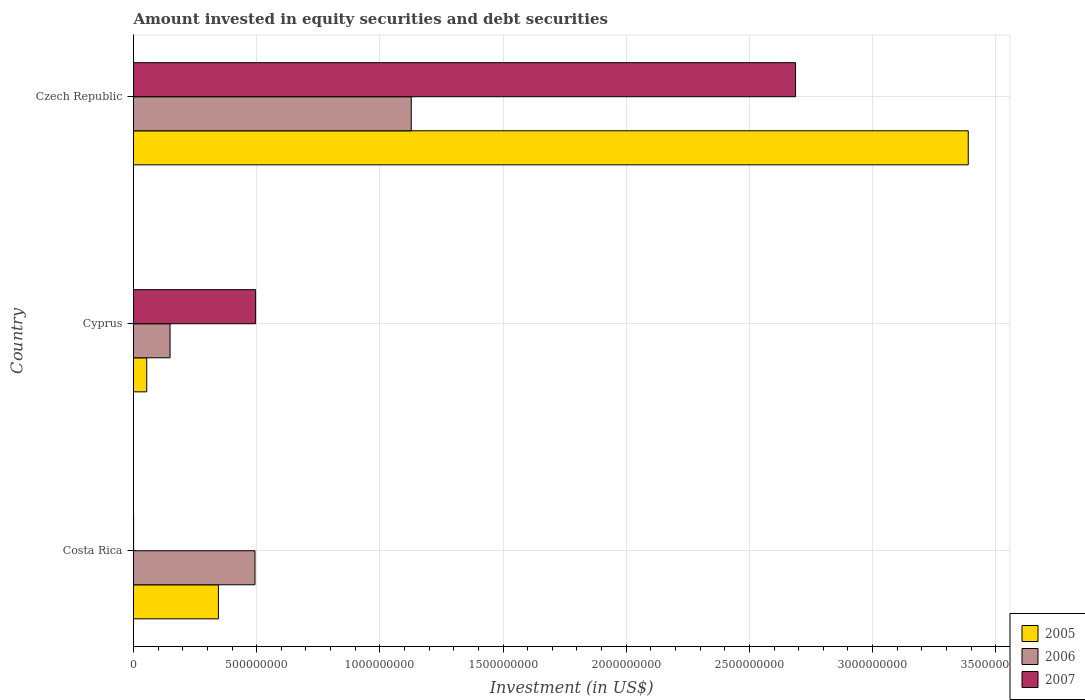How many different coloured bars are there?
Your answer should be compact. 3. How many groups of bars are there?
Give a very brief answer. 3. Are the number of bars on each tick of the Y-axis equal?
Your answer should be very brief. Yes. How many bars are there on the 3rd tick from the top?
Your response must be concise. 3. What is the label of the 2nd group of bars from the top?
Provide a succinct answer. Cyprus. What is the amount invested in equity securities and debt securities in 2006 in Costa Rica?
Ensure brevity in your answer.  4.93e+08. Across all countries, what is the maximum amount invested in equity securities and debt securities in 2005?
Offer a very short reply. 3.39e+09. Across all countries, what is the minimum amount invested in equity securities and debt securities in 2007?
Your response must be concise. 3.93e+05. In which country was the amount invested in equity securities and debt securities in 2006 maximum?
Give a very brief answer. Czech Republic. In which country was the amount invested in equity securities and debt securities in 2007 minimum?
Make the answer very short. Costa Rica. What is the total amount invested in equity securities and debt securities in 2005 in the graph?
Your answer should be very brief. 3.79e+09. What is the difference between the amount invested in equity securities and debt securities in 2006 in Costa Rica and that in Czech Republic?
Provide a succinct answer. -6.34e+08. What is the difference between the amount invested in equity securities and debt securities in 2005 in Czech Republic and the amount invested in equity securities and debt securities in 2006 in Costa Rica?
Provide a succinct answer. 2.90e+09. What is the average amount invested in equity securities and debt securities in 2007 per country?
Provide a short and direct response. 1.06e+09. What is the difference between the amount invested in equity securities and debt securities in 2007 and amount invested in equity securities and debt securities in 2005 in Costa Rica?
Offer a very short reply. -3.44e+08. In how many countries, is the amount invested in equity securities and debt securities in 2006 greater than 300000000 US$?
Your answer should be very brief. 2. What is the ratio of the amount invested in equity securities and debt securities in 2006 in Costa Rica to that in Czech Republic?
Offer a terse response. 0.44. Is the amount invested in equity securities and debt securities in 2005 in Costa Rica less than that in Cyprus?
Offer a very short reply. No. Is the difference between the amount invested in equity securities and debt securities in 2007 in Cyprus and Czech Republic greater than the difference between the amount invested in equity securities and debt securities in 2005 in Cyprus and Czech Republic?
Offer a very short reply. Yes. What is the difference between the highest and the second highest amount invested in equity securities and debt securities in 2005?
Your response must be concise. 3.04e+09. What is the difference between the highest and the lowest amount invested in equity securities and debt securities in 2005?
Offer a terse response. 3.33e+09. In how many countries, is the amount invested in equity securities and debt securities in 2006 greater than the average amount invested in equity securities and debt securities in 2006 taken over all countries?
Ensure brevity in your answer.  1. Is the sum of the amount invested in equity securities and debt securities in 2007 in Cyprus and Czech Republic greater than the maximum amount invested in equity securities and debt securities in 2005 across all countries?
Give a very brief answer. No. What does the 1st bar from the bottom in Czech Republic represents?
Make the answer very short. 2005. Is it the case that in every country, the sum of the amount invested in equity securities and debt securities in 2005 and amount invested in equity securities and debt securities in 2006 is greater than the amount invested in equity securities and debt securities in 2007?
Ensure brevity in your answer.  No. How many bars are there?
Offer a terse response. 9. How many countries are there in the graph?
Give a very brief answer. 3. Where does the legend appear in the graph?
Provide a short and direct response. Bottom right. How many legend labels are there?
Provide a succinct answer. 3. How are the legend labels stacked?
Your answer should be very brief. Vertical. What is the title of the graph?
Offer a very short reply. Amount invested in equity securities and debt securities. Does "1966" appear as one of the legend labels in the graph?
Your response must be concise. No. What is the label or title of the X-axis?
Give a very brief answer. Investment (in US$). What is the Investment (in US$) in 2005 in Costa Rica?
Your response must be concise. 3.45e+08. What is the Investment (in US$) of 2006 in Costa Rica?
Your response must be concise. 4.93e+08. What is the Investment (in US$) in 2007 in Costa Rica?
Make the answer very short. 3.93e+05. What is the Investment (in US$) of 2005 in Cyprus?
Offer a terse response. 5.37e+07. What is the Investment (in US$) of 2006 in Cyprus?
Provide a short and direct response. 1.48e+08. What is the Investment (in US$) of 2007 in Cyprus?
Your response must be concise. 4.96e+08. What is the Investment (in US$) in 2005 in Czech Republic?
Provide a short and direct response. 3.39e+09. What is the Investment (in US$) of 2006 in Czech Republic?
Your answer should be very brief. 1.13e+09. What is the Investment (in US$) of 2007 in Czech Republic?
Provide a short and direct response. 2.69e+09. Across all countries, what is the maximum Investment (in US$) in 2005?
Offer a very short reply. 3.39e+09. Across all countries, what is the maximum Investment (in US$) in 2006?
Provide a succinct answer. 1.13e+09. Across all countries, what is the maximum Investment (in US$) of 2007?
Your response must be concise. 2.69e+09. Across all countries, what is the minimum Investment (in US$) in 2005?
Offer a terse response. 5.37e+07. Across all countries, what is the minimum Investment (in US$) in 2006?
Your answer should be compact. 1.48e+08. Across all countries, what is the minimum Investment (in US$) in 2007?
Keep it short and to the point. 3.93e+05. What is the total Investment (in US$) in 2005 in the graph?
Keep it short and to the point. 3.79e+09. What is the total Investment (in US$) in 2006 in the graph?
Offer a very short reply. 1.77e+09. What is the total Investment (in US$) of 2007 in the graph?
Give a very brief answer. 3.18e+09. What is the difference between the Investment (in US$) in 2005 in Costa Rica and that in Cyprus?
Give a very brief answer. 2.91e+08. What is the difference between the Investment (in US$) of 2006 in Costa Rica and that in Cyprus?
Provide a short and direct response. 3.45e+08. What is the difference between the Investment (in US$) of 2007 in Costa Rica and that in Cyprus?
Give a very brief answer. -4.95e+08. What is the difference between the Investment (in US$) of 2005 in Costa Rica and that in Czech Republic?
Provide a short and direct response. -3.04e+09. What is the difference between the Investment (in US$) of 2006 in Costa Rica and that in Czech Republic?
Your response must be concise. -6.34e+08. What is the difference between the Investment (in US$) of 2007 in Costa Rica and that in Czech Republic?
Provide a short and direct response. -2.69e+09. What is the difference between the Investment (in US$) of 2005 in Cyprus and that in Czech Republic?
Provide a short and direct response. -3.33e+09. What is the difference between the Investment (in US$) in 2006 in Cyprus and that in Czech Republic?
Keep it short and to the point. -9.79e+08. What is the difference between the Investment (in US$) of 2007 in Cyprus and that in Czech Republic?
Offer a very short reply. -2.19e+09. What is the difference between the Investment (in US$) in 2005 in Costa Rica and the Investment (in US$) in 2006 in Cyprus?
Provide a short and direct response. 1.96e+08. What is the difference between the Investment (in US$) of 2005 in Costa Rica and the Investment (in US$) of 2007 in Cyprus?
Make the answer very short. -1.51e+08. What is the difference between the Investment (in US$) of 2006 in Costa Rica and the Investment (in US$) of 2007 in Cyprus?
Give a very brief answer. -2.46e+06. What is the difference between the Investment (in US$) in 2005 in Costa Rica and the Investment (in US$) in 2006 in Czech Republic?
Keep it short and to the point. -7.83e+08. What is the difference between the Investment (in US$) in 2005 in Costa Rica and the Investment (in US$) in 2007 in Czech Republic?
Ensure brevity in your answer.  -2.34e+09. What is the difference between the Investment (in US$) of 2006 in Costa Rica and the Investment (in US$) of 2007 in Czech Republic?
Your answer should be compact. -2.19e+09. What is the difference between the Investment (in US$) of 2005 in Cyprus and the Investment (in US$) of 2006 in Czech Republic?
Provide a short and direct response. -1.07e+09. What is the difference between the Investment (in US$) of 2005 in Cyprus and the Investment (in US$) of 2007 in Czech Republic?
Provide a short and direct response. -2.63e+09. What is the difference between the Investment (in US$) in 2006 in Cyprus and the Investment (in US$) in 2007 in Czech Republic?
Provide a short and direct response. -2.54e+09. What is the average Investment (in US$) in 2005 per country?
Offer a very short reply. 1.26e+09. What is the average Investment (in US$) of 2006 per country?
Provide a short and direct response. 5.90e+08. What is the average Investment (in US$) of 2007 per country?
Your answer should be very brief. 1.06e+09. What is the difference between the Investment (in US$) in 2005 and Investment (in US$) in 2006 in Costa Rica?
Offer a terse response. -1.49e+08. What is the difference between the Investment (in US$) in 2005 and Investment (in US$) in 2007 in Costa Rica?
Provide a succinct answer. 3.44e+08. What is the difference between the Investment (in US$) in 2006 and Investment (in US$) in 2007 in Costa Rica?
Keep it short and to the point. 4.93e+08. What is the difference between the Investment (in US$) in 2005 and Investment (in US$) in 2006 in Cyprus?
Ensure brevity in your answer.  -9.46e+07. What is the difference between the Investment (in US$) in 2005 and Investment (in US$) in 2007 in Cyprus?
Offer a very short reply. -4.42e+08. What is the difference between the Investment (in US$) of 2006 and Investment (in US$) of 2007 in Cyprus?
Offer a terse response. -3.47e+08. What is the difference between the Investment (in US$) of 2005 and Investment (in US$) of 2006 in Czech Republic?
Your answer should be compact. 2.26e+09. What is the difference between the Investment (in US$) of 2005 and Investment (in US$) of 2007 in Czech Republic?
Your answer should be compact. 7.01e+08. What is the difference between the Investment (in US$) of 2006 and Investment (in US$) of 2007 in Czech Republic?
Your answer should be compact. -1.56e+09. What is the ratio of the Investment (in US$) in 2005 in Costa Rica to that in Cyprus?
Keep it short and to the point. 6.41. What is the ratio of the Investment (in US$) of 2006 in Costa Rica to that in Cyprus?
Give a very brief answer. 3.32. What is the ratio of the Investment (in US$) of 2007 in Costa Rica to that in Cyprus?
Provide a succinct answer. 0. What is the ratio of the Investment (in US$) of 2005 in Costa Rica to that in Czech Republic?
Provide a succinct answer. 0.1. What is the ratio of the Investment (in US$) in 2006 in Costa Rica to that in Czech Republic?
Keep it short and to the point. 0.44. What is the ratio of the Investment (in US$) of 2005 in Cyprus to that in Czech Republic?
Offer a very short reply. 0.02. What is the ratio of the Investment (in US$) in 2006 in Cyprus to that in Czech Republic?
Offer a very short reply. 0.13. What is the ratio of the Investment (in US$) of 2007 in Cyprus to that in Czech Republic?
Ensure brevity in your answer.  0.18. What is the difference between the highest and the second highest Investment (in US$) in 2005?
Provide a succinct answer. 3.04e+09. What is the difference between the highest and the second highest Investment (in US$) of 2006?
Your answer should be very brief. 6.34e+08. What is the difference between the highest and the second highest Investment (in US$) of 2007?
Your answer should be compact. 2.19e+09. What is the difference between the highest and the lowest Investment (in US$) in 2005?
Ensure brevity in your answer.  3.33e+09. What is the difference between the highest and the lowest Investment (in US$) of 2006?
Your answer should be compact. 9.79e+08. What is the difference between the highest and the lowest Investment (in US$) in 2007?
Provide a succinct answer. 2.69e+09. 